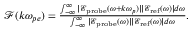Convert formula to latex. <formula><loc_0><loc_0><loc_500><loc_500>\begin{array} { r } { \mathcal { F } ( k \omega _ { p e } ) = \frac { \int _ { - \infty } ^ { \infty } | \mathcal { E } _ { p r o b e } ( \omega + k \omega _ { p } ) | | \mathcal { E } _ { r e f } ( \omega ) | d \omega } { \int _ { - \infty } ^ { \infty } | \mathcal { E } _ { p r o b e } ( \omega ) | | \mathcal { E } _ { r e f } ( \omega ) | d \omega } . } \end{array}</formula> 